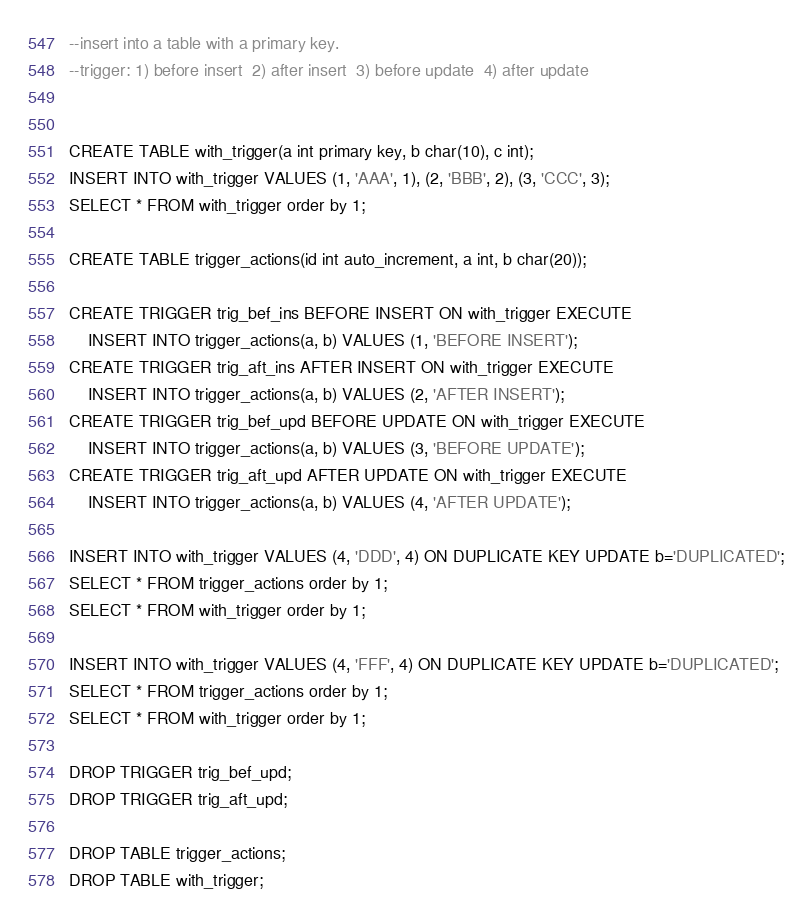Convert code to text. <code><loc_0><loc_0><loc_500><loc_500><_SQL_>--insert into a table with a primary key.
--trigger: 1) before insert  2) after insert  3) before update  4) after update


CREATE TABLE with_trigger(a int primary key, b char(10), c int);
INSERT INTO with_trigger VALUES (1, 'AAA', 1), (2, 'BBB', 2), (3, 'CCC', 3);
SELECT * FROM with_trigger order by 1;

CREATE TABLE trigger_actions(id int auto_increment, a int, b char(20));

CREATE TRIGGER trig_bef_ins BEFORE INSERT ON with_trigger EXECUTE
	INSERT INTO trigger_actions(a, b) VALUES (1, 'BEFORE INSERT');
CREATE TRIGGER trig_aft_ins AFTER INSERT ON with_trigger EXECUTE
	INSERT INTO trigger_actions(a, b) VALUES (2, 'AFTER INSERT');
CREATE TRIGGER trig_bef_upd BEFORE UPDATE ON with_trigger EXECUTE
	INSERT INTO trigger_actions(a, b) VALUES (3, 'BEFORE UPDATE');
CREATE TRIGGER trig_aft_upd AFTER UPDATE ON with_trigger EXECUTE
	INSERT INTO trigger_actions(a, b) VALUES (4, 'AFTER UPDATE');

INSERT INTO with_trigger VALUES (4, 'DDD', 4) ON DUPLICATE KEY UPDATE b='DUPLICATED';
SELECT * FROM trigger_actions order by 1;
SELECT * FROM with_trigger order by 1;

INSERT INTO with_trigger VALUES (4, 'FFF', 4) ON DUPLICATE KEY UPDATE b='DUPLICATED';
SELECT * FROM trigger_actions order by 1;
SELECT * FROM with_trigger order by 1;

DROP TRIGGER trig_bef_upd;
DROP TRIGGER trig_aft_upd;

DROP TABLE trigger_actions;
DROP TABLE with_trigger;
</code> 